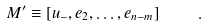<formula> <loc_0><loc_0><loc_500><loc_500>M ^ { \prime } \equiv \left [ u _ { - } , e _ { 2 } , \dots , e _ { n - m } \right ] \quad .</formula> 